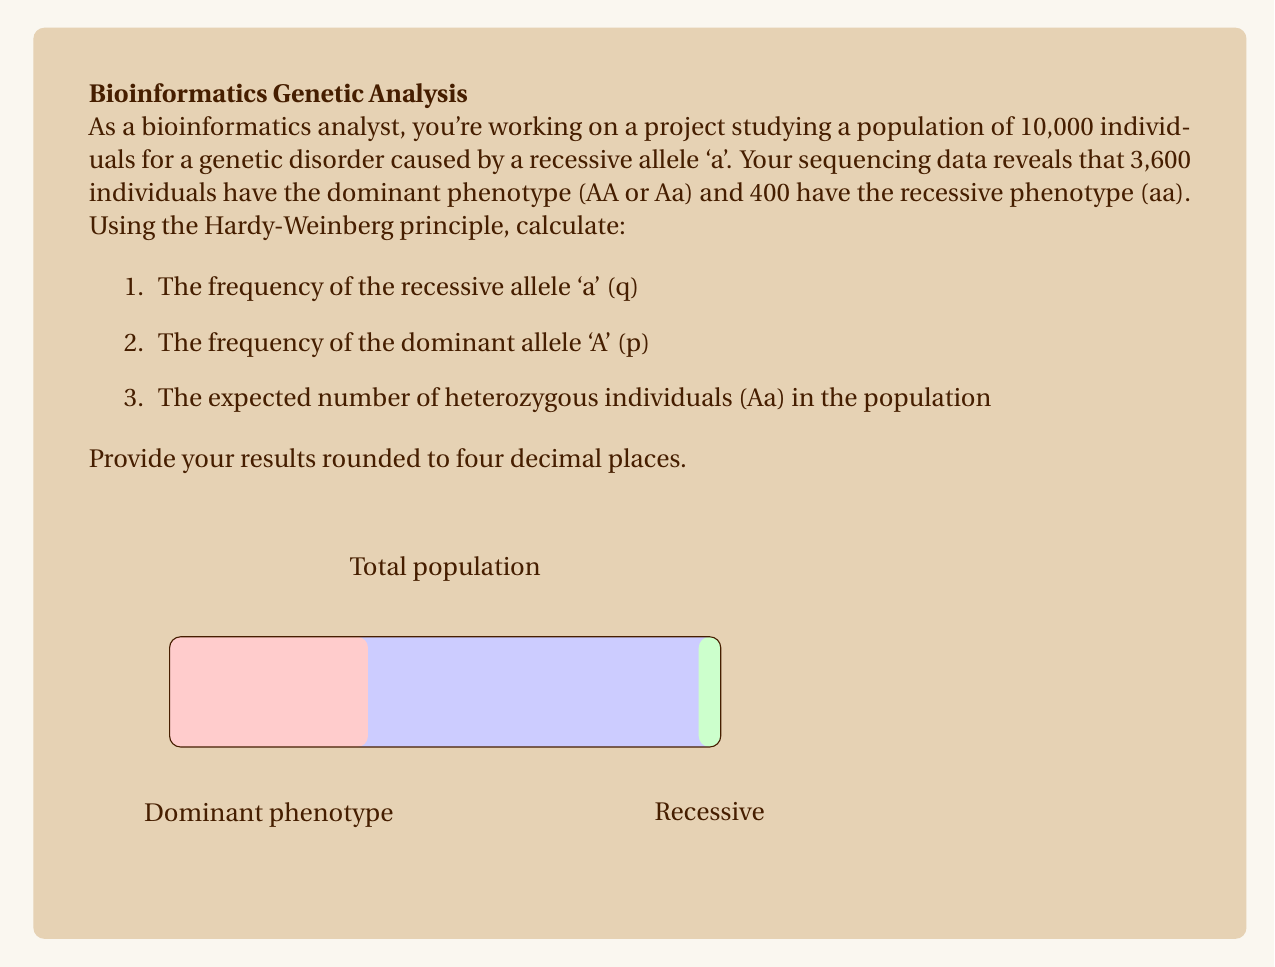Help me with this question. Let's solve this problem step-by-step using the Hardy-Weinberg principle:

1. Calculate the frequency of the recessive allele 'a' (q):
   - The recessive phenotype (aa) frequency is 400/10000 = 0.04
   - This represents $q^2$ in the Hardy-Weinberg equation
   - So, $q = \sqrt{0.04} = 0.2$

2. Calculate the frequency of the dominant allele 'A' (p):
   - In the Hardy-Weinberg principle, $p + q = 1$
   - Therefore, $p = 1 - q = 1 - 0.2 = 0.8$

3. Calculate the expected number of heterozygous individuals (Aa):
   - The frequency of heterozygotes is given by $2pq$ in the Hardy-Weinberg equation
   - $2pq = 2 * 0.8 * 0.2 = 0.32$
   - The number of heterozygous individuals = $0.32 * 10,000 = 3,200$

Verification:
We can verify our calculations using the Hardy-Weinberg equation:
$p^2 + 2pq + q^2 = 1$
$(0.8)^2 + 2(0.8)(0.2) + (0.2)^2 = 0.64 + 0.32 + 0.04 = 1$

This confirms that our calculations are correct and the population is in Hardy-Weinberg equilibrium.
Answer: 1. q = 0.2000
2. p = 0.8000
3. 3,200 heterozygous individuals 